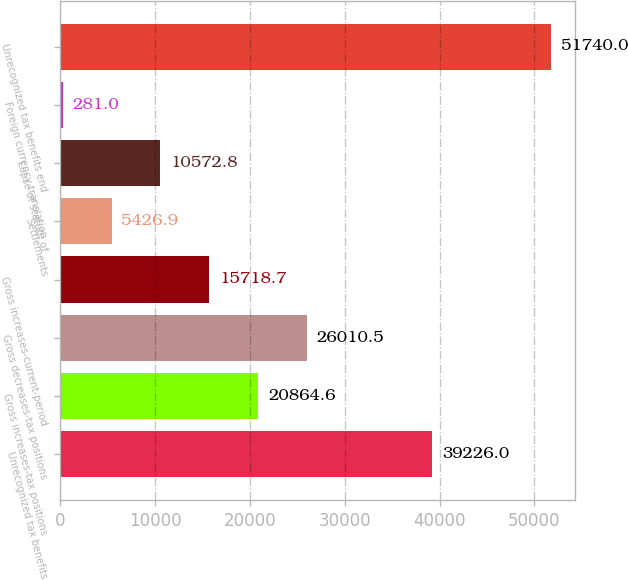Convert chart to OTSL. <chart><loc_0><loc_0><loc_500><loc_500><bar_chart><fcel>Unrecognized tax benefits<fcel>Gross increases-tax positions<fcel>Gross decreases-tax positions<fcel>Gross increases-current-period<fcel>Settlements<fcel>Lapse of statute of<fcel>Foreign currency translation<fcel>Unrecognized tax benefits end<nl><fcel>39226<fcel>20864.6<fcel>26010.5<fcel>15718.7<fcel>5426.9<fcel>10572.8<fcel>281<fcel>51740<nl></chart> 